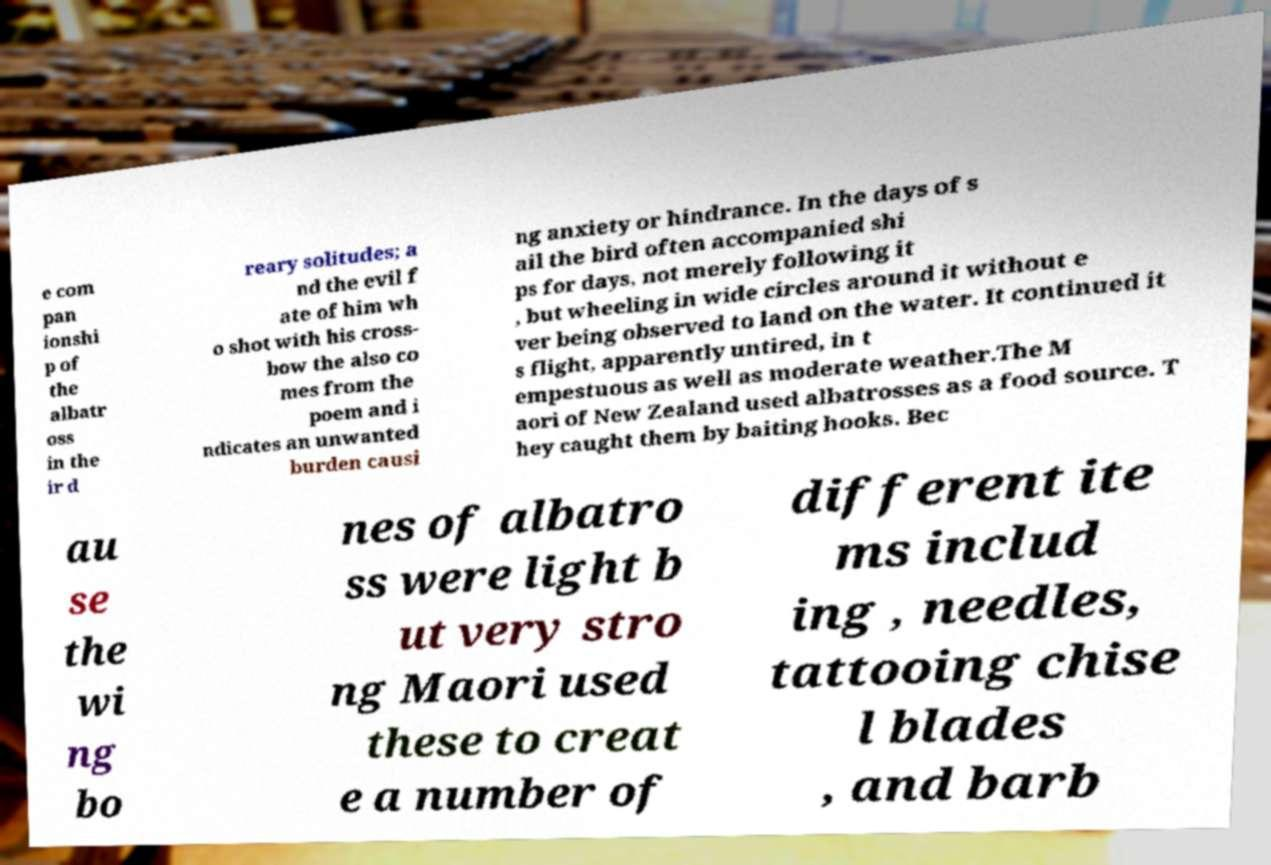There's text embedded in this image that I need extracted. Can you transcribe it verbatim? e com pan ionshi p of the albatr oss in the ir d reary solitudes; a nd the evil f ate of him wh o shot with his cross- bow the also co mes from the poem and i ndicates an unwanted burden causi ng anxiety or hindrance. In the days of s ail the bird often accompanied shi ps for days, not merely following it , but wheeling in wide circles around it without e ver being observed to land on the water. It continued it s flight, apparently untired, in t empestuous as well as moderate weather.The M aori of New Zealand used albatrosses as a food source. T hey caught them by baiting hooks. Bec au se the wi ng bo nes of albatro ss were light b ut very stro ng Maori used these to creat e a number of different ite ms includ ing , needles, tattooing chise l blades , and barb 